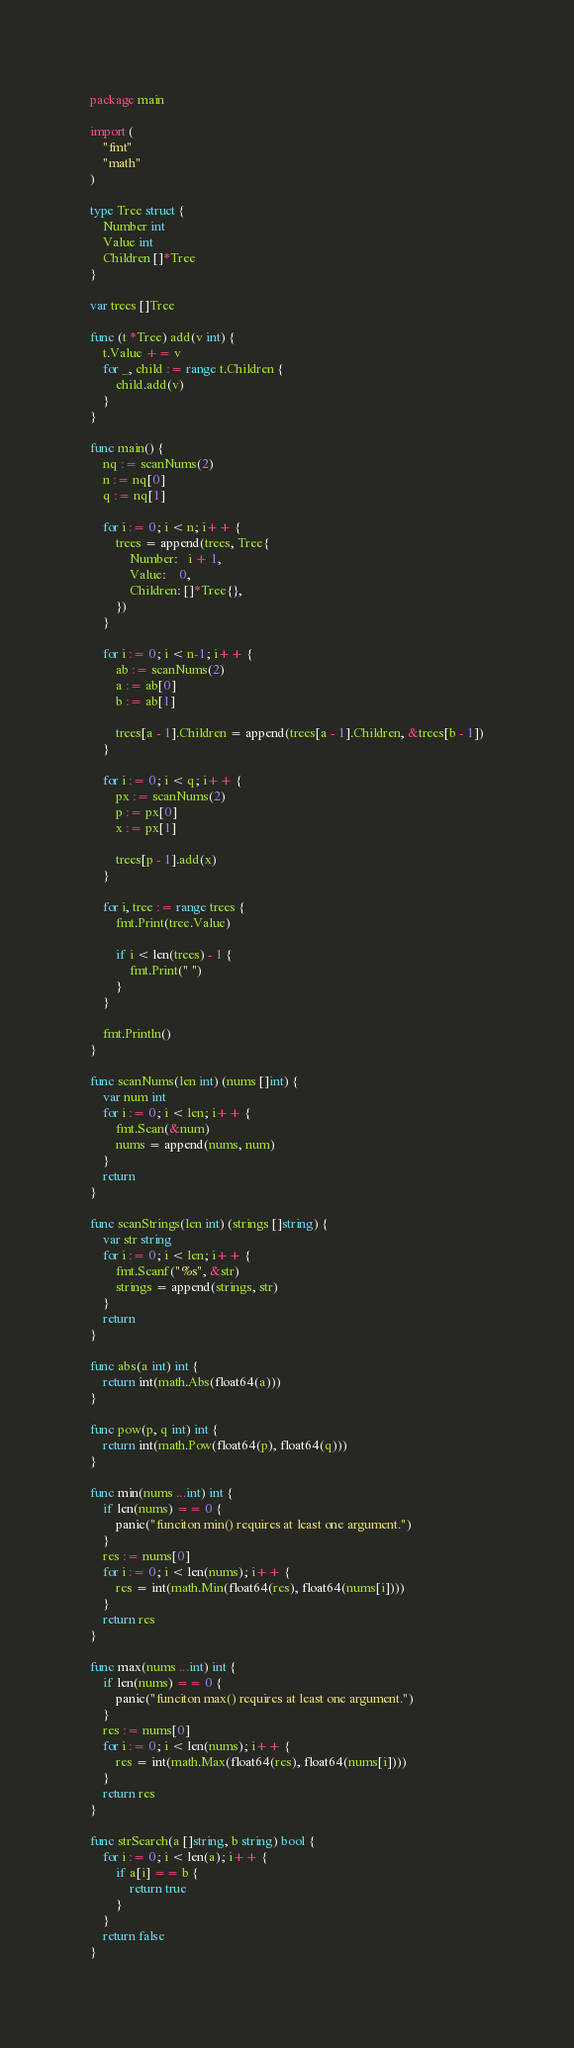Convert code to text. <code><loc_0><loc_0><loc_500><loc_500><_Go_>package main

import (
	"fmt"
	"math"
)

type Tree struct {
	Number int
	Value int
	Children []*Tree
}

var trees []Tree

func (t *Tree) add(v int) {
	t.Value += v
	for _, child := range t.Children {
		child.add(v)
	}
}

func main() {
	nq := scanNums(2)
	n := nq[0]
	q := nq[1]

	for i := 0; i < n; i++ {
		trees = append(trees, Tree{
			Number:   i + 1,
			Value:    0,
			Children: []*Tree{},
		})
	}

	for i := 0; i < n-1; i++ {
		ab := scanNums(2)
		a := ab[0]
		b := ab[1]

		trees[a - 1].Children = append(trees[a - 1].Children, &trees[b - 1])
	}

	for i := 0; i < q; i++ {
		px := scanNums(2)
		p := px[0]
		x := px[1]

		trees[p - 1].add(x)
	}

	for i, tree := range trees {
		fmt.Print(tree.Value)

		if i < len(trees) - 1 {
			fmt.Print(" ")
		}
	}

	fmt.Println()
}

func scanNums(len int) (nums []int) {
	var num int
	for i := 0; i < len; i++ {
		fmt.Scan(&num)
		nums = append(nums, num)
	}
	return
}

func scanStrings(len int) (strings []string) {
	var str string
	for i := 0; i < len; i++ {
		fmt.Scanf("%s", &str)
		strings = append(strings, str)
	}
	return
}

func abs(a int) int {
	return int(math.Abs(float64(a)))
}

func pow(p, q int) int {
	return int(math.Pow(float64(p), float64(q)))
}

func min(nums ...int) int {
	if len(nums) == 0 {
		panic("funciton min() requires at least one argument.")
	}
	res := nums[0]
	for i := 0; i < len(nums); i++ {
		res = int(math.Min(float64(res), float64(nums[i])))
	}
	return res
}

func max(nums ...int) int {
	if len(nums) == 0 {
		panic("funciton max() requires at least one argument.")
	}
	res := nums[0]
	for i := 0; i < len(nums); i++ {
		res = int(math.Max(float64(res), float64(nums[i])))
	}
	return res
}

func strSearch(a []string, b string) bool {
	for i := 0; i < len(a); i++ {
		if a[i] == b {
			return true
		}
	}
	return false
}
</code> 